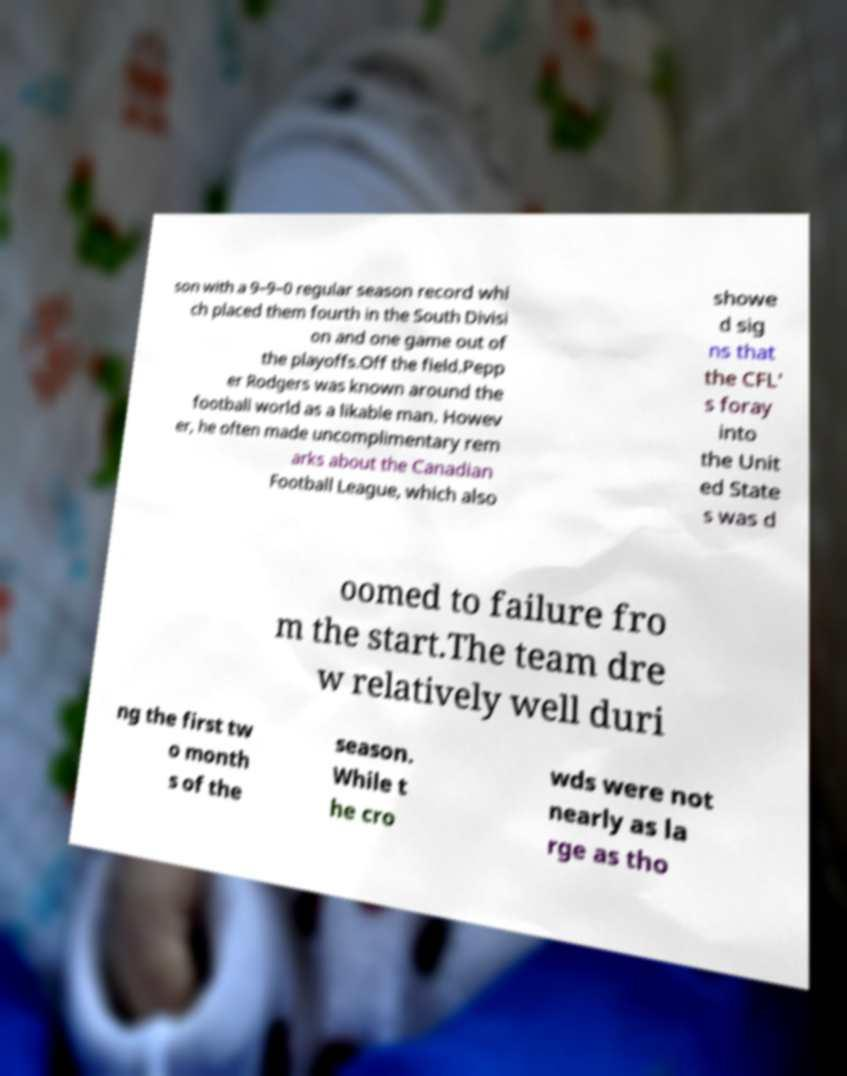What messages or text are displayed in this image? I need them in a readable, typed format. son with a 9–9–0 regular season record whi ch placed them fourth in the South Divisi on and one game out of the playoffs.Off the field.Pepp er Rodgers was known around the football world as a likable man. Howev er, he often made uncomplimentary rem arks about the Canadian Football League, which also showe d sig ns that the CFL' s foray into the Unit ed State s was d oomed to failure fro m the start.The team dre w relatively well duri ng the first tw o month s of the season. While t he cro wds were not nearly as la rge as tho 